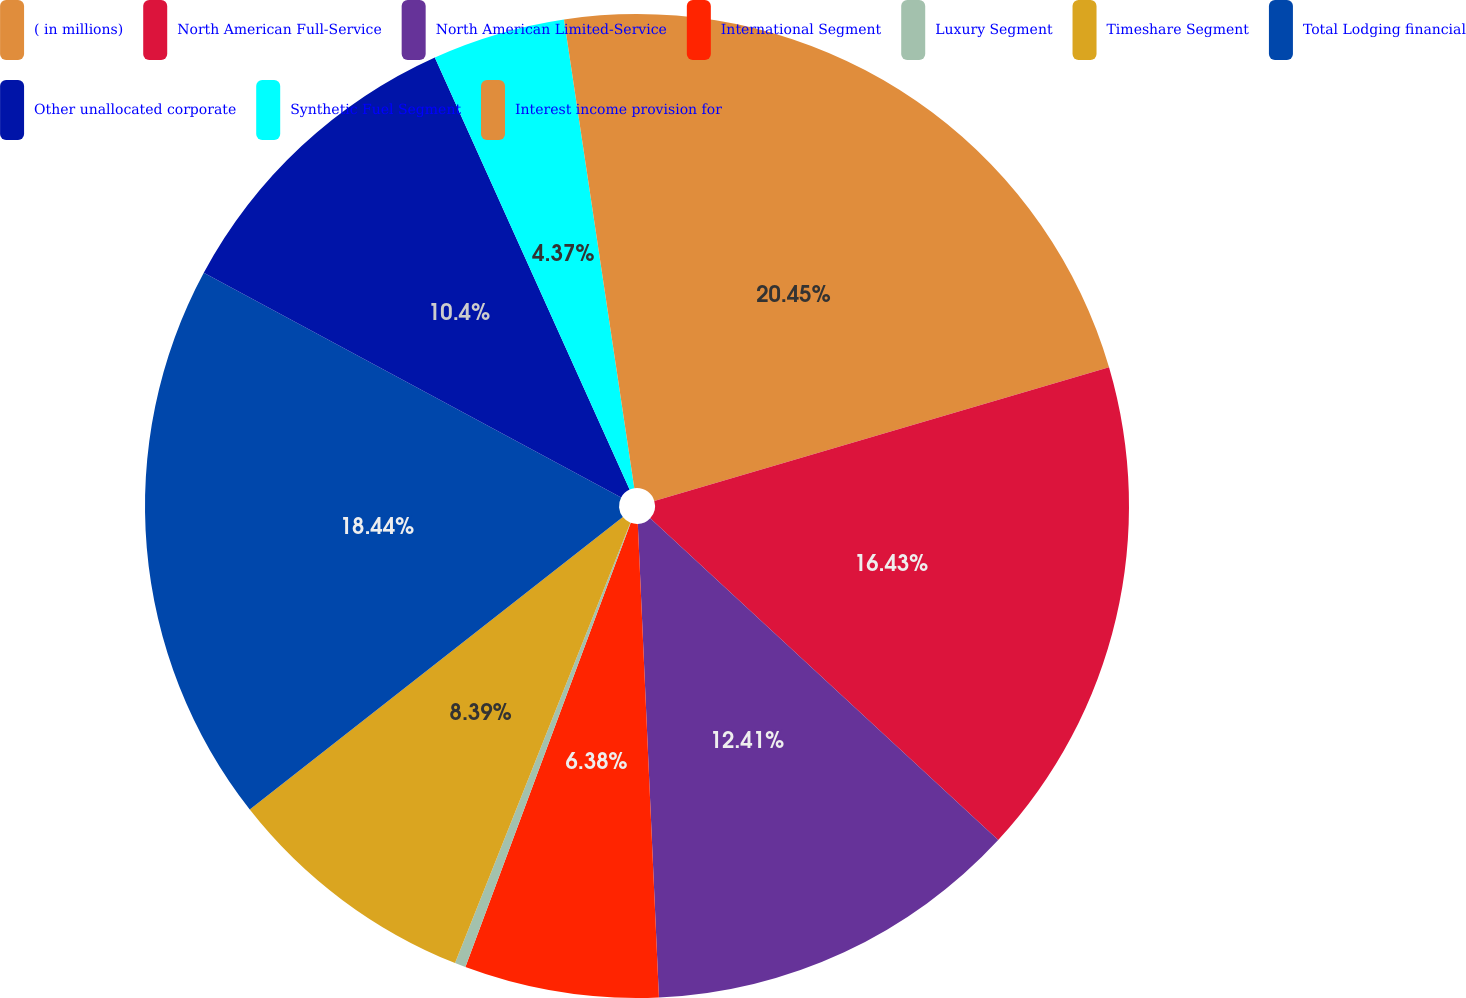<chart> <loc_0><loc_0><loc_500><loc_500><pie_chart><fcel>( in millions)<fcel>North American Full-Service<fcel>North American Limited-Service<fcel>International Segment<fcel>Luxury Segment<fcel>Timeshare Segment<fcel>Total Lodging financial<fcel>Other unallocated corporate<fcel>Synthetic Fuel Segment<fcel>Interest income provision for<nl><fcel>20.45%<fcel>16.43%<fcel>12.41%<fcel>6.38%<fcel>0.36%<fcel>8.39%<fcel>18.44%<fcel>10.4%<fcel>4.37%<fcel>2.37%<nl></chart> 